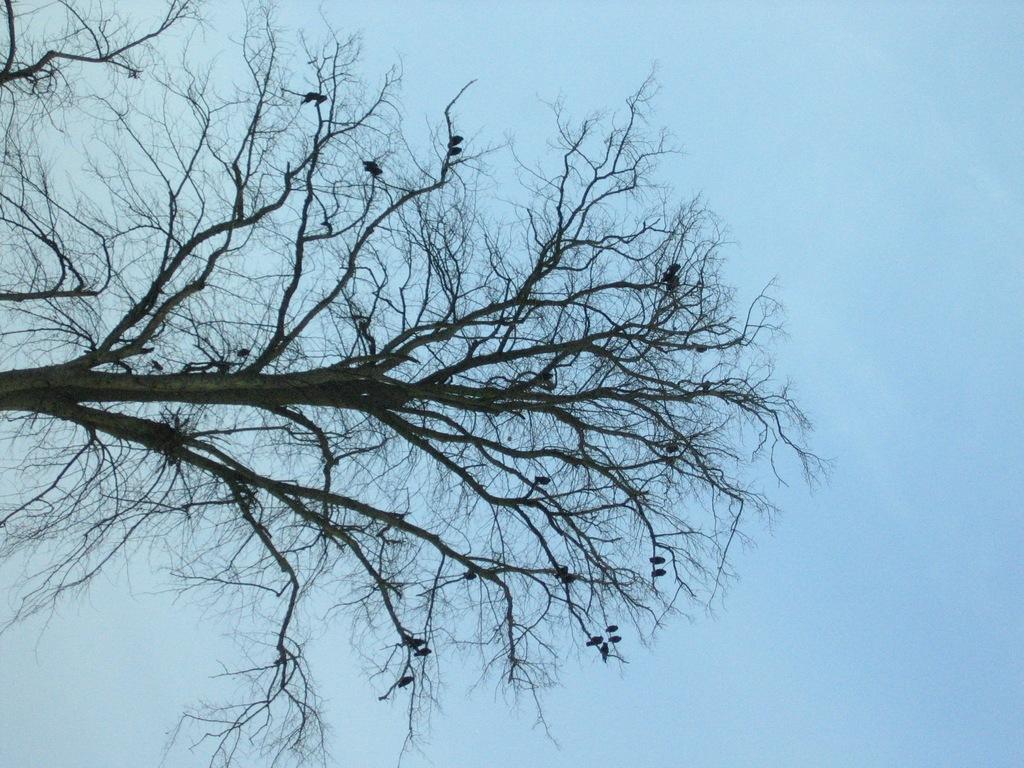In one or two sentences, can you explain what this image depicts? In this image I can see branches of a tree and the sky in the background. 